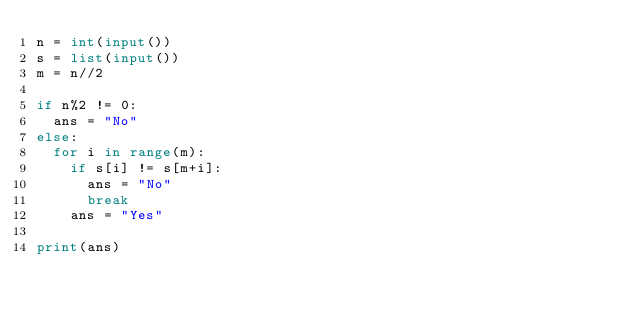Convert code to text. <code><loc_0><loc_0><loc_500><loc_500><_Python_>n = int(input())
s = list(input())
m = n//2

if n%2 != 0:
  ans = "No"
else:
  for i in range(m):
    if s[i] != s[m+i]:
      ans = "No"
      break
    ans = "Yes"

print(ans)</code> 